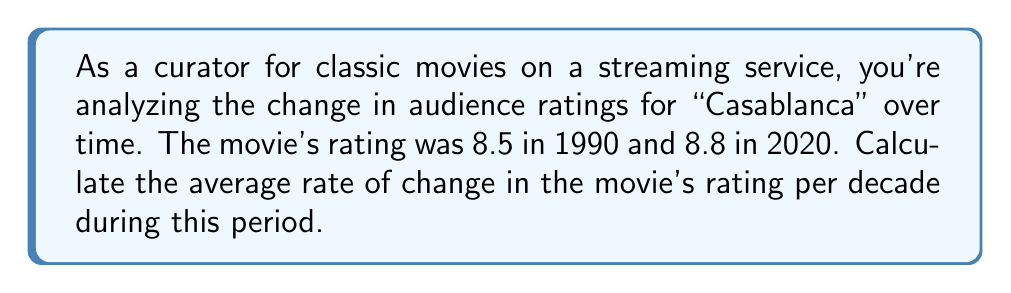Help me with this question. To solve this problem, we'll follow these steps:

1. Identify the given information:
   - Initial rating in 1990: 8.5
   - Final rating in 2020: 8.8
   - Time period: 2020 - 1990 = 30 years

2. Calculate the total change in rating:
   $\Delta \text{rating} = \text{Final rating} - \text{Initial rating}$
   $\Delta \text{rating} = 8.8 - 8.5 = 0.3$

3. Calculate the rate of change per year:
   $$\text{Rate of change per year} = \frac{\Delta \text{rating}}{\Delta \text{time in years}}$$
   $$\text{Rate of change per year} = \frac{0.3}{30} = 0.01 \text{ per year}$$

4. Convert the rate of change to per decade:
   $$\text{Rate of change per decade} = 0.01 \times 10 = 0.1$$

Therefore, the average rate of change in the movie's rating per decade is 0.1.
Answer: 0.1 per decade 